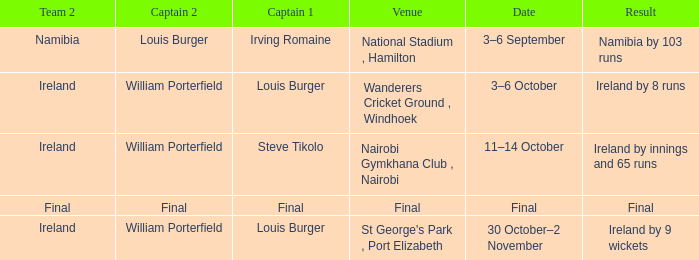Which Result has a Captain 2 of louis burger? Namibia by 103 runs. 